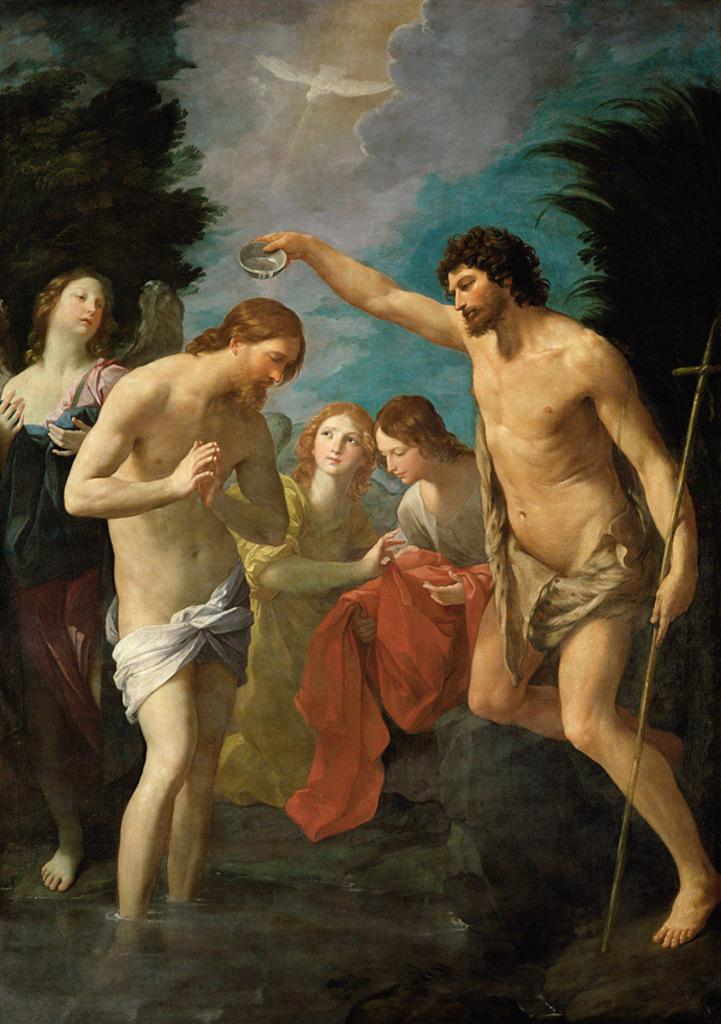How many people are in the image? There are people in the image, but the exact number is not specified. What is the person holding in the image? One person is holding a stick and a bowl in the image. What can be seen in the background of the image? There are trees visible in the background of the image. What is the medium of the image? The image is painted. What type of clouds can be seen in the image? There are no clouds visible in the image, as it is a painted scene. What is the mass of the bowl being held by the person in the image? The mass of the bowl cannot be determined from the image alone, as it depends on the material and size of the bowl. 